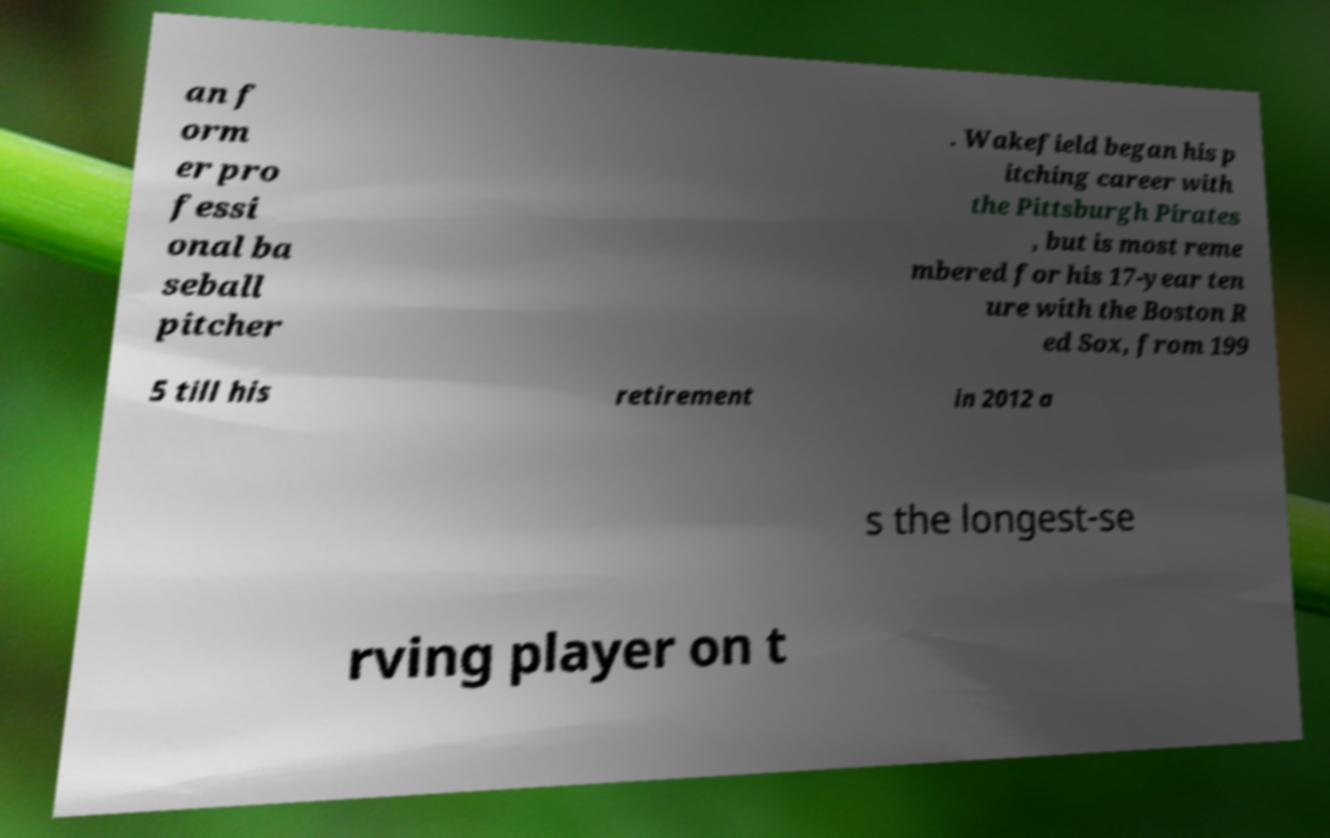What messages or text are displayed in this image? I need them in a readable, typed format. an f orm er pro fessi onal ba seball pitcher . Wakefield began his p itching career with the Pittsburgh Pirates , but is most reme mbered for his 17-year ten ure with the Boston R ed Sox, from 199 5 till his retirement in 2012 a s the longest-se rving player on t 